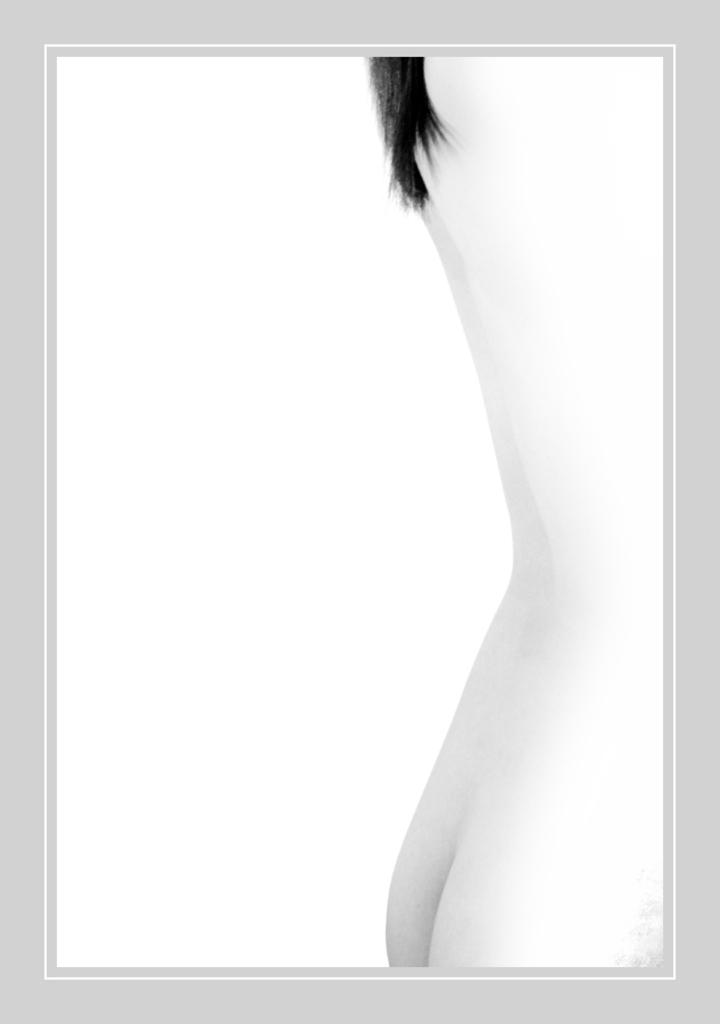What is the color scheme of the image? The image is black and white. Can you describe the person in the image? There is a person on the right side of the image. What is the background of the image? The background of the image is white. What type of plant is growing on the person's shoulder in the image? There is no plant visible on the person's shoulder in the image. 